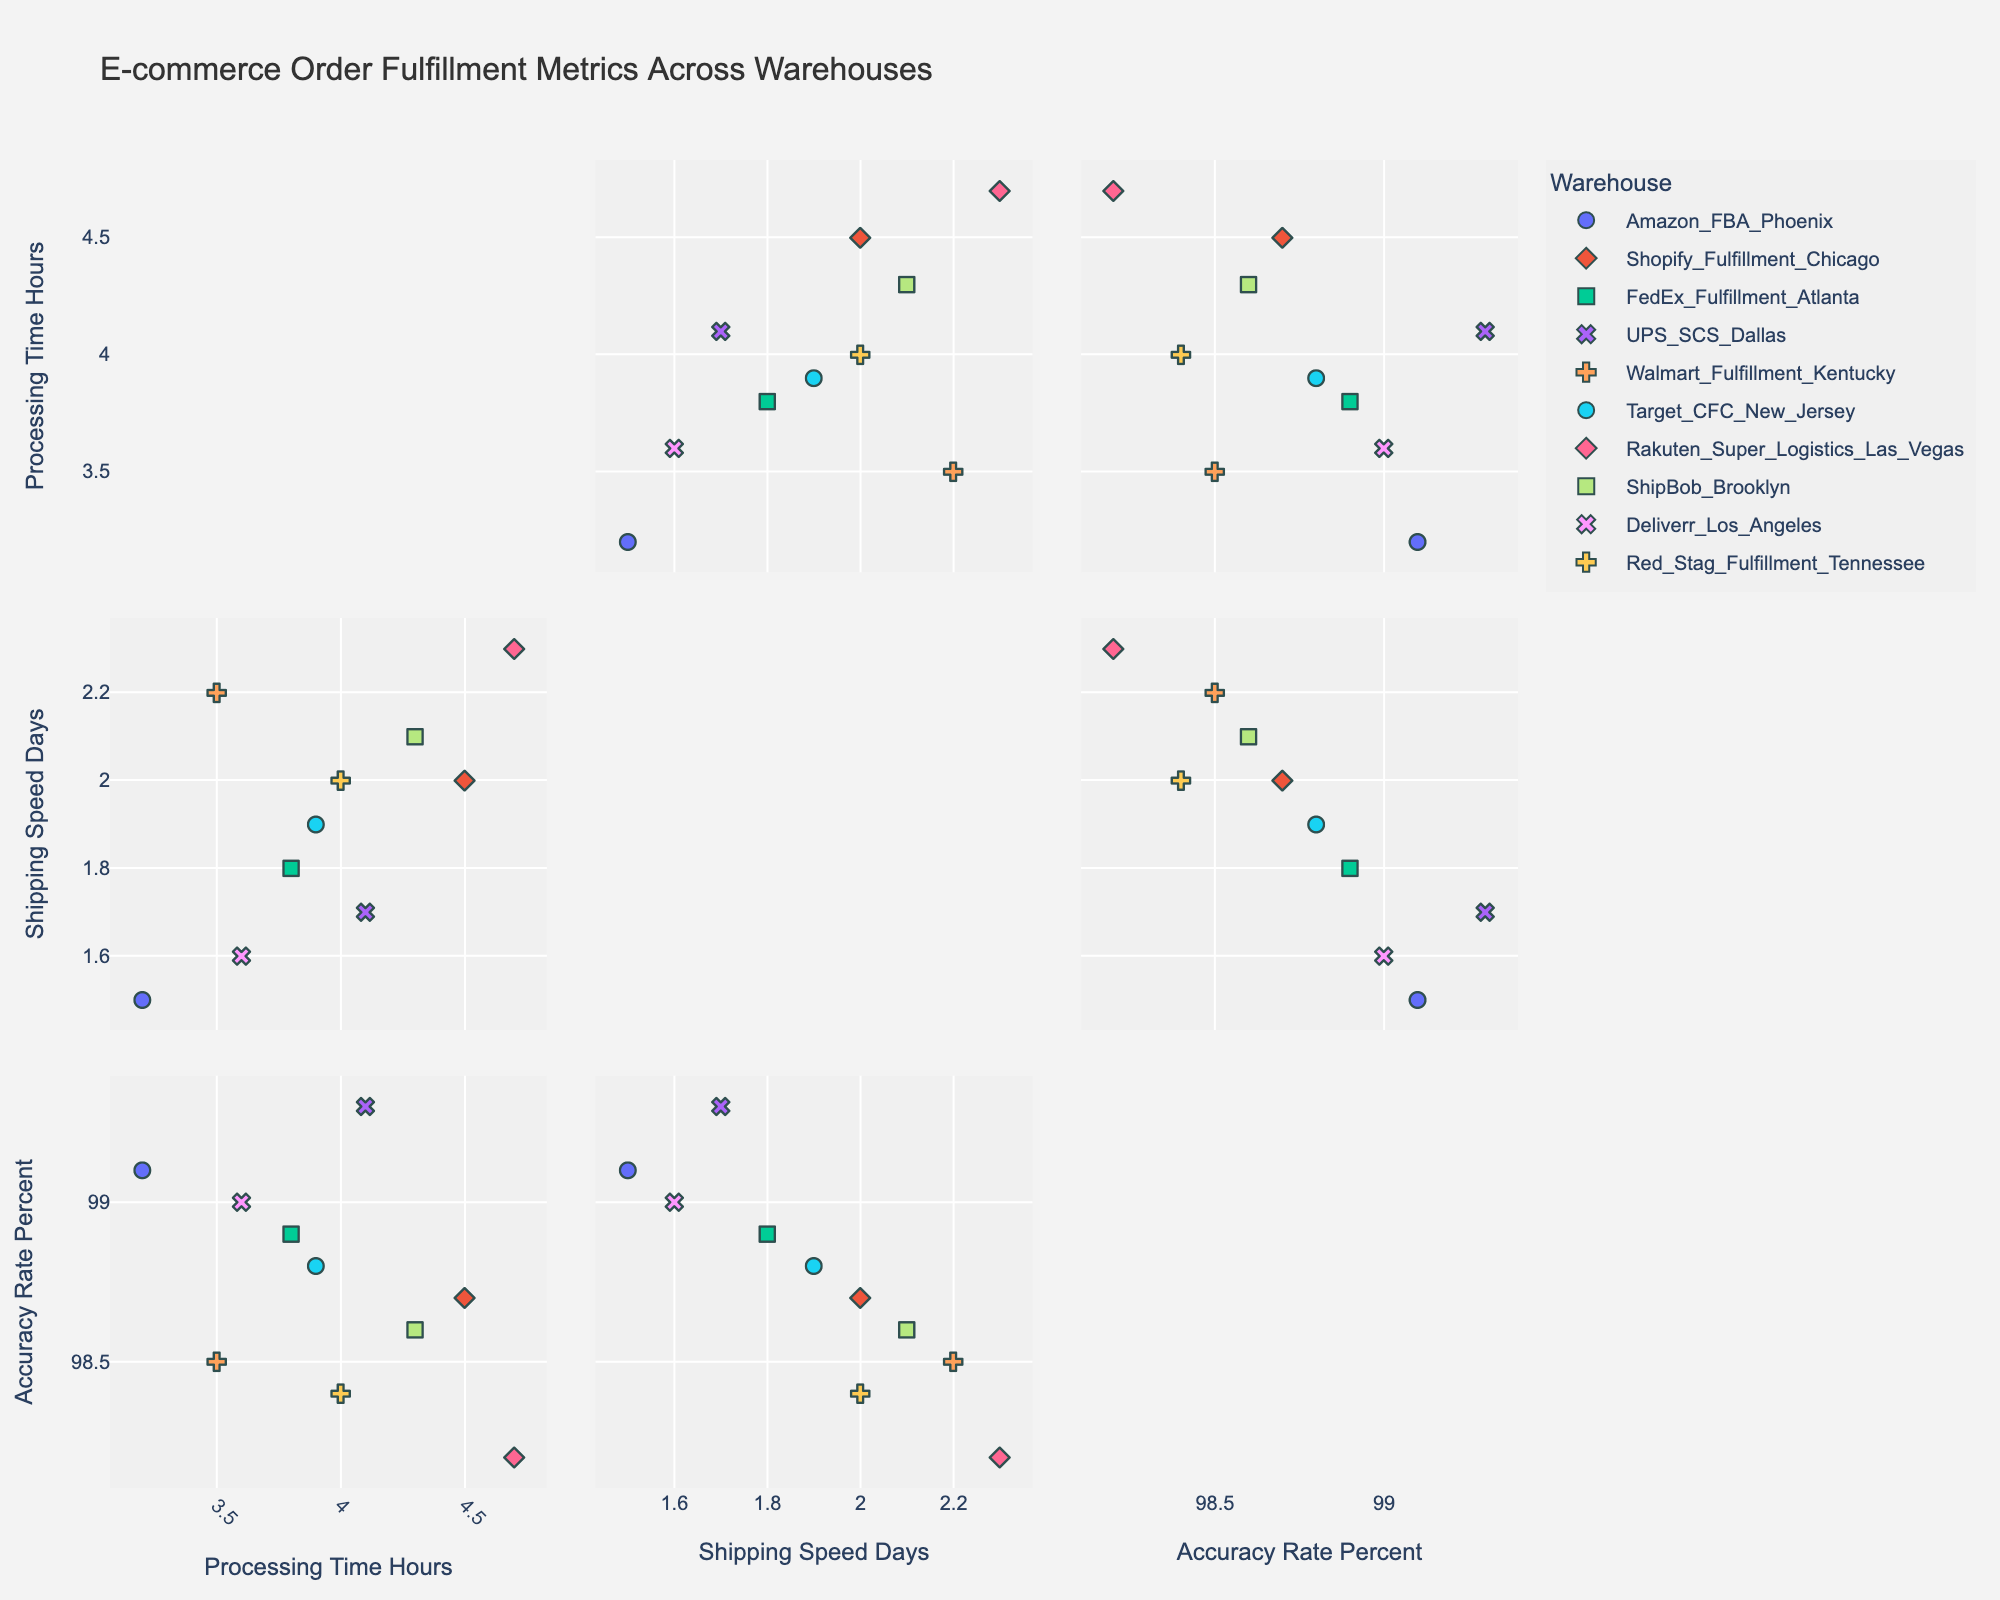What's the title of the figure? The title is located at the top center of the figure. It provides a summary of what the figure represents.
Answer: E-commerce Order Fulfillment Metrics Across Warehouses How many warehouses are represented in the scatterplot matrix? Each different symbol and color represents a distinct warehouse. Counting these distinct markers, there are 10 unique warehouses.
Answer: 10 What is the axis label for the x-axis in the 'Processing Time Hours' vs. 'Shipping Speed Days' scatterplot? The x-axis label in this scatterplot corresponds to 'Processing Time Hours,' as indicated along the axis.
Answer: Processing Time Hours Which warehouse has the highest processing time? Identify the highest data point on the 'Processing Time Hours' axis and trace it to the corresponding warehouse symbol, which represents Rakuten Super Logistics Las Vegas at 4.7 hours.
Answer: Rakuten Super Logistics Las Vegas What is the average shipping speed across all warehouses? Sum all shipping speed values (1.5 + 2.0 + 1.8 + 1.7 + 2.2 + 1.9 + 2.3 + 2.1 + 1.6 + 2.0 = 19.1) and divide by the number of warehouses (10) to find the average.
Answer: 1.91 days Which two warehouses have the closest accuracy rates? Compare the data points' values for 'Accuracy Rate Percent' and identify the pair with the smallest difference, which are Amazon FBA Phoenix (99.1%) and UPS SCS Dallas (99.3%).
Answer: Amazon FBA Phoenix and UPS SCS Dallas Which warehouse has the best combination of fast shipping speed and high accuracy rate? By looking at warehouse data points that are both higher on the 'Accuracy Rate Percent' axis and lower on the 'Shipping Speed Days' axis, the point representing Amazon FBA Phoenix (99.1% accuracy rate and 1.5 days shipping speed) fits this best.
Answer: Amazon FBA Phoenix Is there a warehouse with high processing time but also high accuracy rates? Identify data points with high values on the 'Processing Time Hours' axis and cross-check with high values on the 'Accuracy Rate Percent' axis. Rakuten Super Logistics Las Vegas (4.7 hours processing, 98.2% accuracy) meets this condition.
Answer: Rakuten Super Logistics Las Vegas How does the processing time generally correlate with shipping speed? Look for the trend among the scatter points; if higher processing times generally align with higher shipping speeds, there's a positive correlation. Visual inspection suggests there is no strong correlation.
Answer: No strong correlation Which warehouse has the fastest shipping speed and what is its accuracy rate? Identify the lowest value on the 'Shipping Speed Days' axis and check its corresponding data point for 'Accuracy Rate Percent'. Deliverr Los Angeles is the fastest with 1.6 days shipping speed and 99.0% accuracy rate.
Answer: Deliverr Los Angeles, 99.0% 